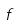Convert formula to latex. <formula><loc_0><loc_0><loc_500><loc_500>f</formula> 